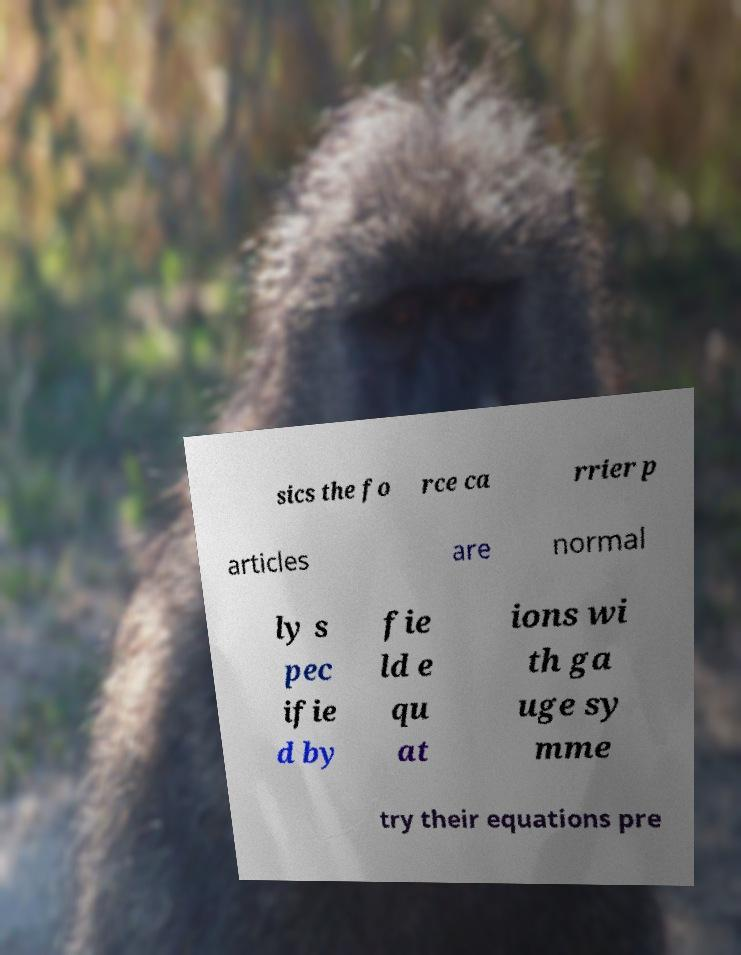I need the written content from this picture converted into text. Can you do that? sics the fo rce ca rrier p articles are normal ly s pec ifie d by fie ld e qu at ions wi th ga uge sy mme try their equations pre 